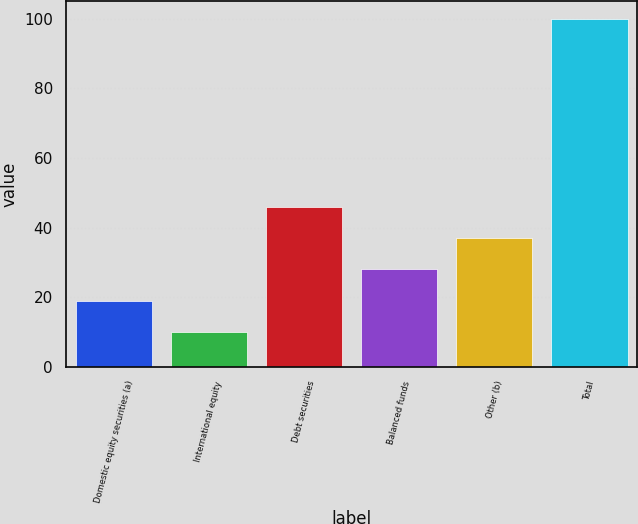Convert chart. <chart><loc_0><loc_0><loc_500><loc_500><bar_chart><fcel>Domestic equity securities (a)<fcel>International equity<fcel>Debt securities<fcel>Balanced funds<fcel>Other (b)<fcel>Total<nl><fcel>19<fcel>10<fcel>46<fcel>28<fcel>37<fcel>100<nl></chart> 